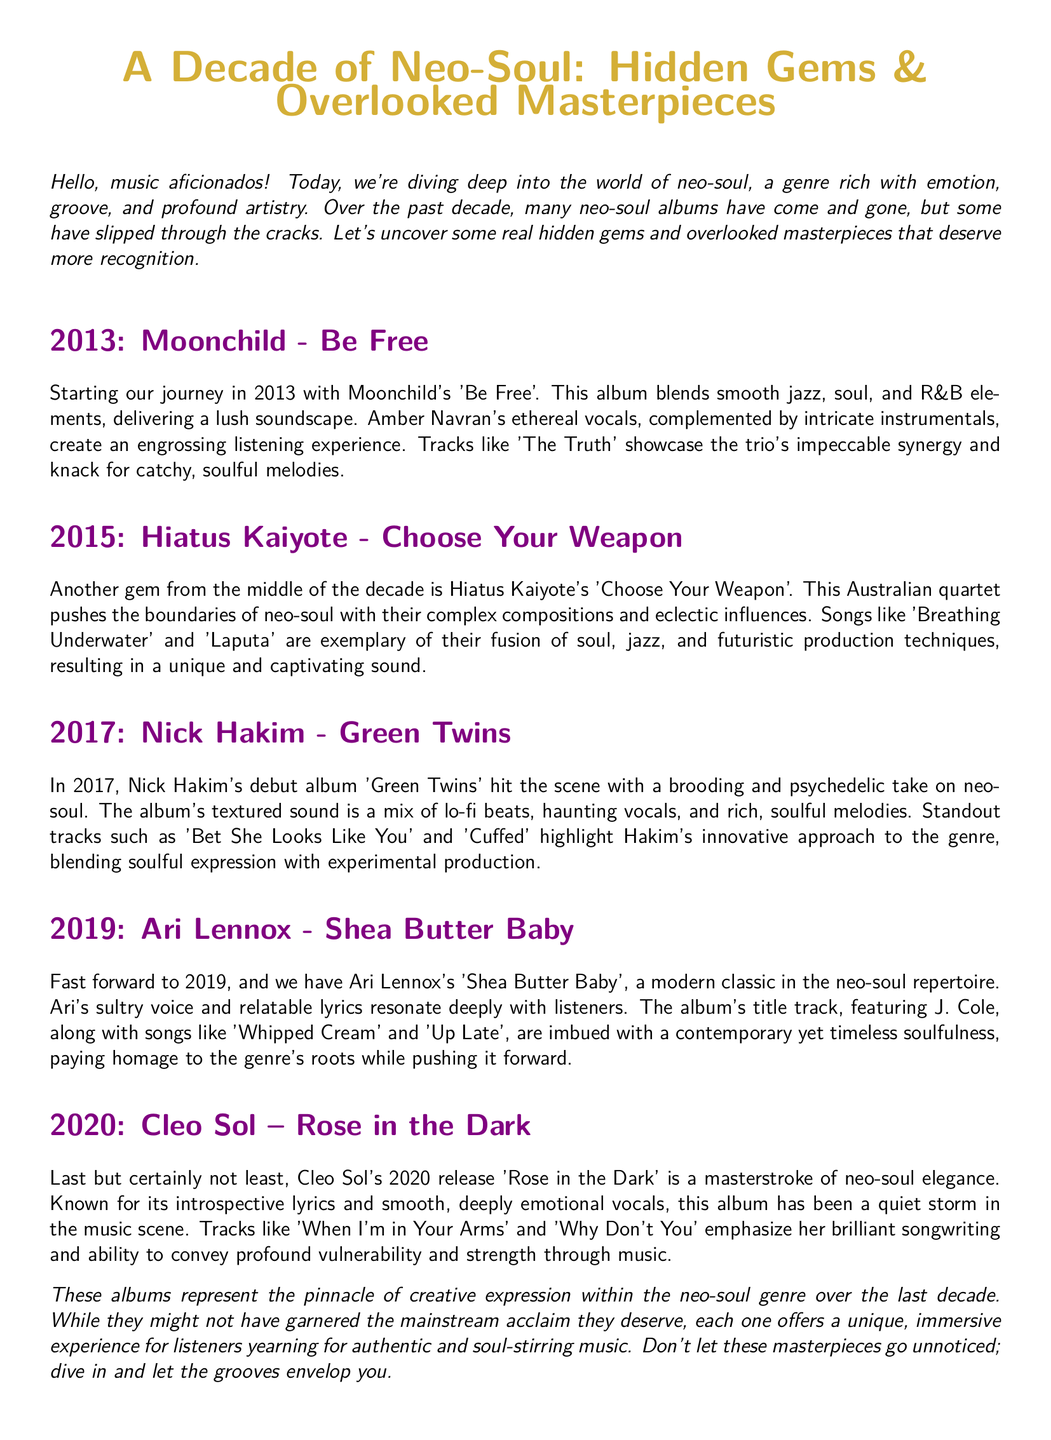What is the title of Moonchild's 2013 album? The title is mentioned in the section header for 2013, specifically calling it 'Be Free'.
Answer: Be Free Which album features the track 'Breathing Underwater'? The track 'Breathing Underwater' is highlighted in the section for Hiatus Kaiyote's album from 2015.
Answer: Choose Your Weapon What year was Nick Hakim's album 'Green Twins' released? The specific year is stated at the beginning of the section dedicated to Nick Hakim, which is 2017.
Answer: 2017 Which artist collaborated with Ari Lennox on the title track of 'Shea Butter Baby'? The collaboration detail is provided in the section for Ari Lennox, mentioning J. Cole.
Answer: J. Cole What genre is primarily discussed in this document? The document focuses on the neo-soul genre, as outlined in the introduction and throughout the sections.
Answer: Neo-soul What common theme is emphasized across the albums reviewed? The themes of creativity and artistic expression are repeated throughout the document, showcasing the albums' innovative qualities.
Answer: Creative expression How many albums are reviewed in the document? The total number of albums mentioned can be counted from the sections, which include five distinct albums discussed.
Answer: Five Which year saw the release of Cleo Sol's 'Rose in the Dark'? The release year is specifically indicated in the section dedicated to Cleo Sol, which mentions 2020.
Answer: 2020 What is a noted characteristic of Cleo Sol's music in the document? Cleo Sol's music is described as having introspective lyrics and smooth, deeply emotional vocals in her section.
Answer: Introspective lyrics and smooth vocals 